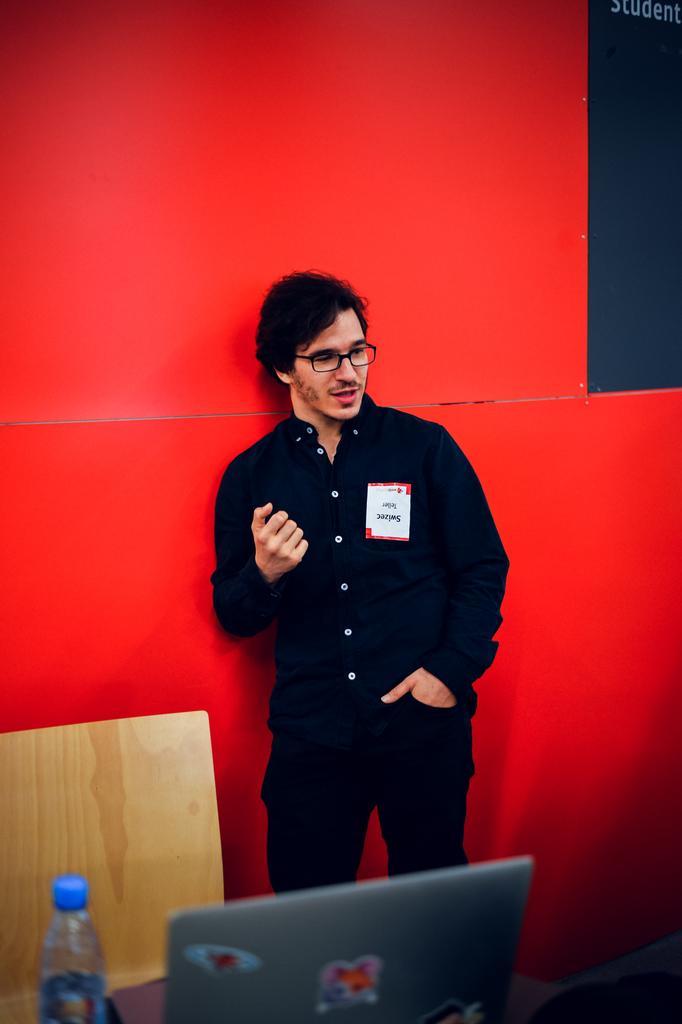In one or two sentences, can you explain what this image depicts? In this image we can see a person standing and we can also see a bottle, laptop and wooden object. 